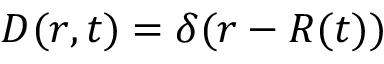Convert formula to latex. <formula><loc_0><loc_0><loc_500><loc_500>{ D ( r , t ) = \delta ( r - R ( t ) ) }</formula> 